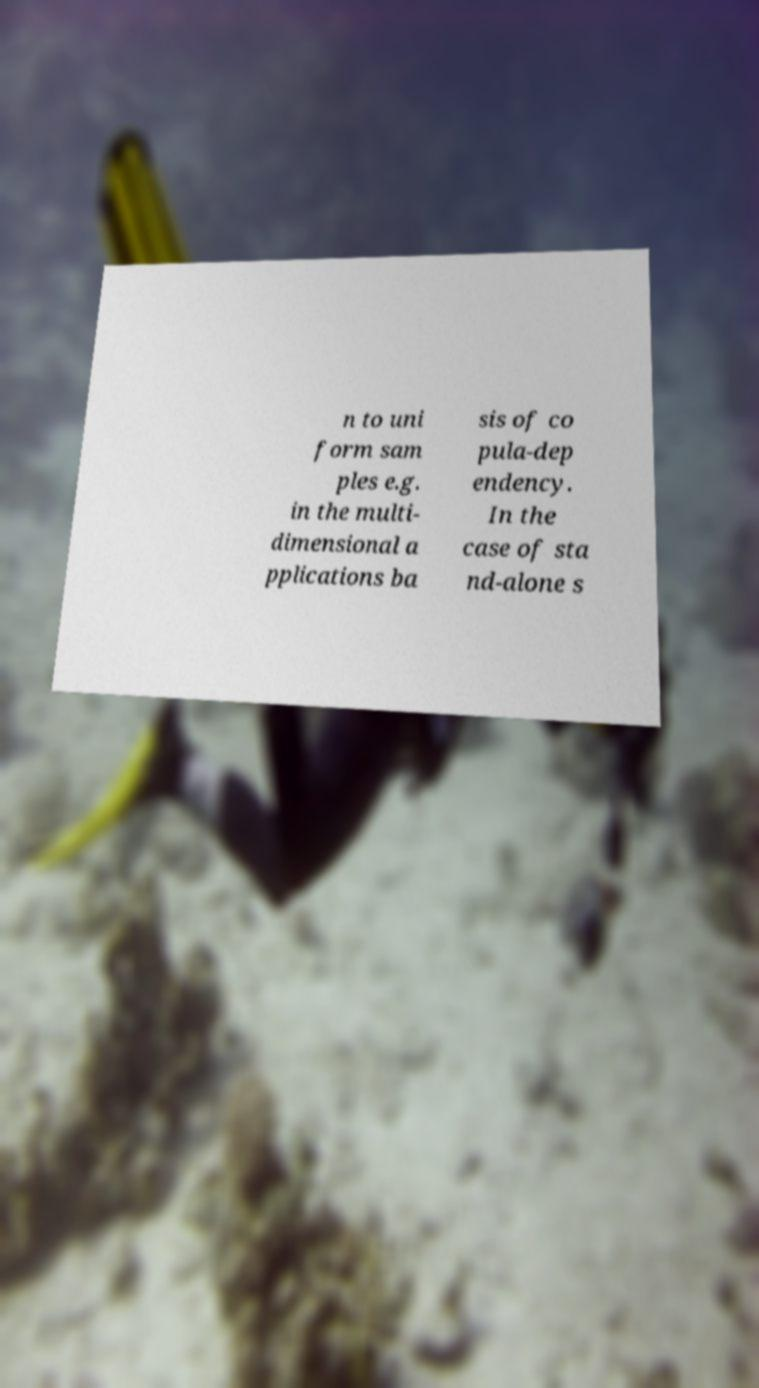I need the written content from this picture converted into text. Can you do that? n to uni form sam ples e.g. in the multi- dimensional a pplications ba sis of co pula-dep endency. In the case of sta nd-alone s 